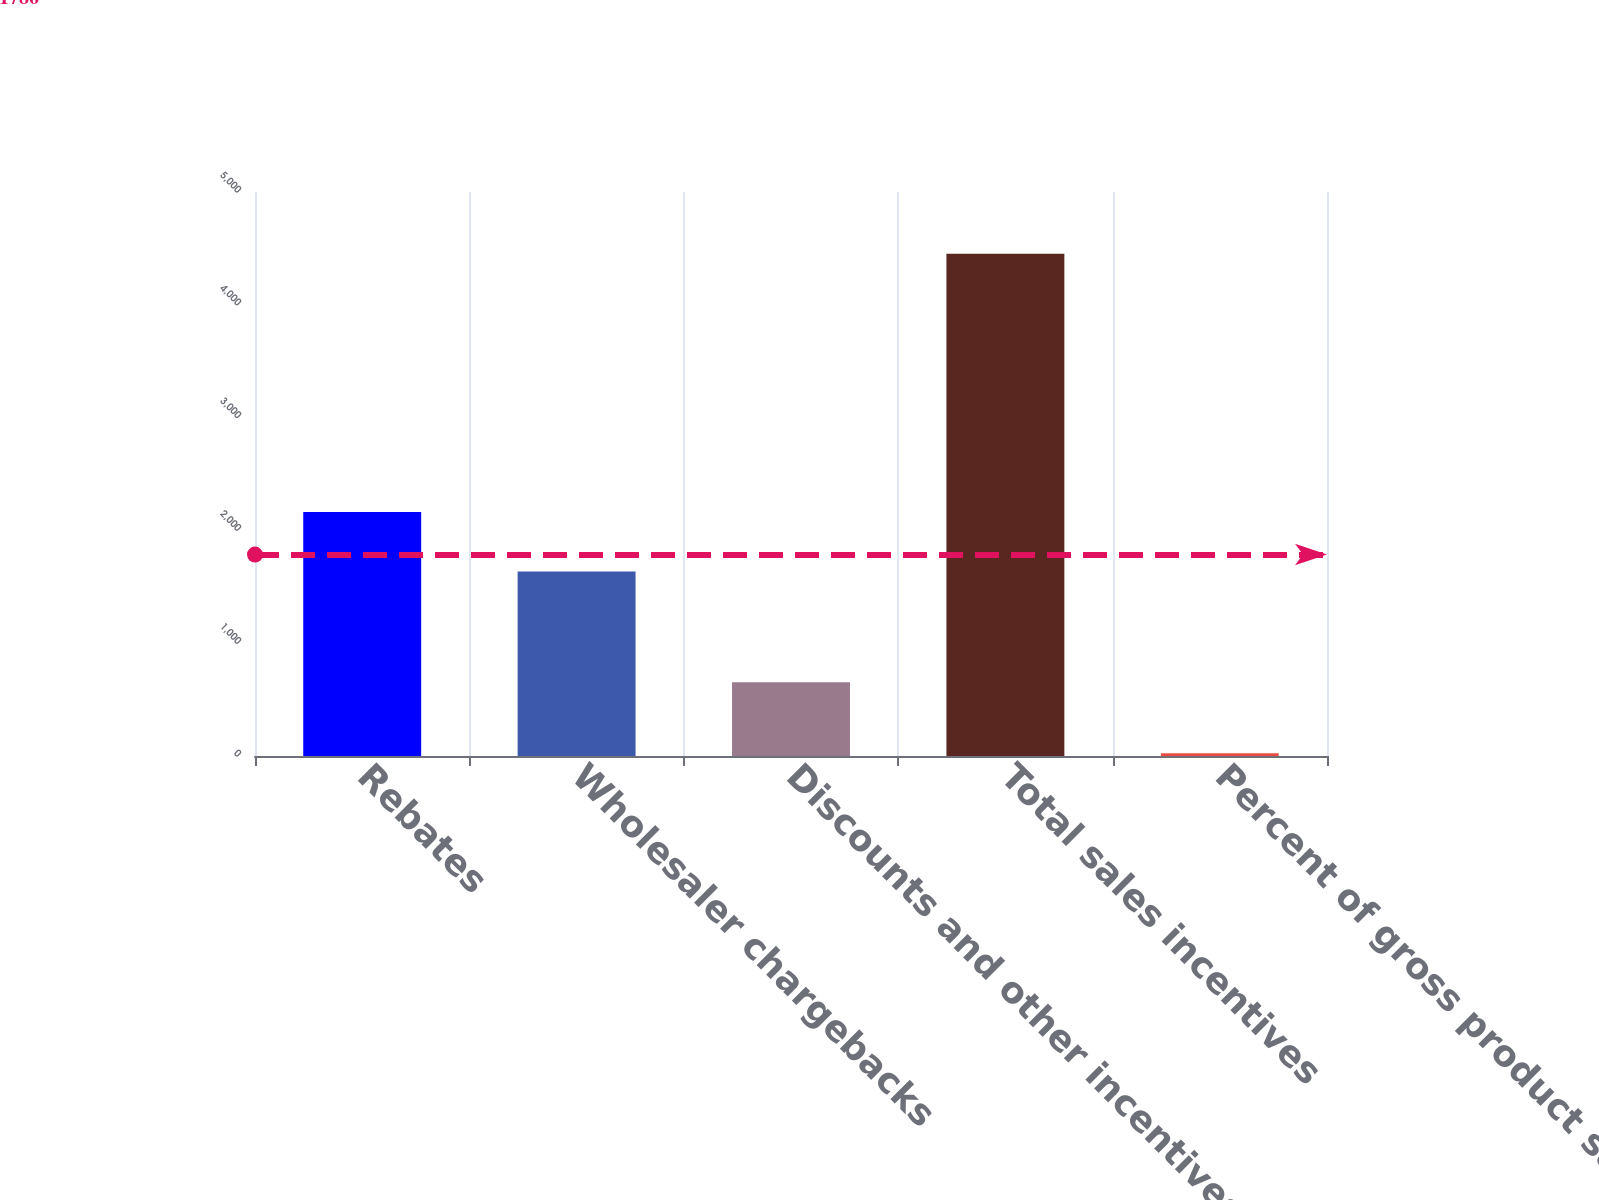Convert chart. <chart><loc_0><loc_0><loc_500><loc_500><bar_chart><fcel>Rebates<fcel>Wholesaler chargebacks<fcel>Discounts and other incentives<fcel>Total sales incentives<fcel>Percent of gross product sales<nl><fcel>2164<fcel>1636<fcel>653<fcel>4453<fcel>24<nl></chart> 